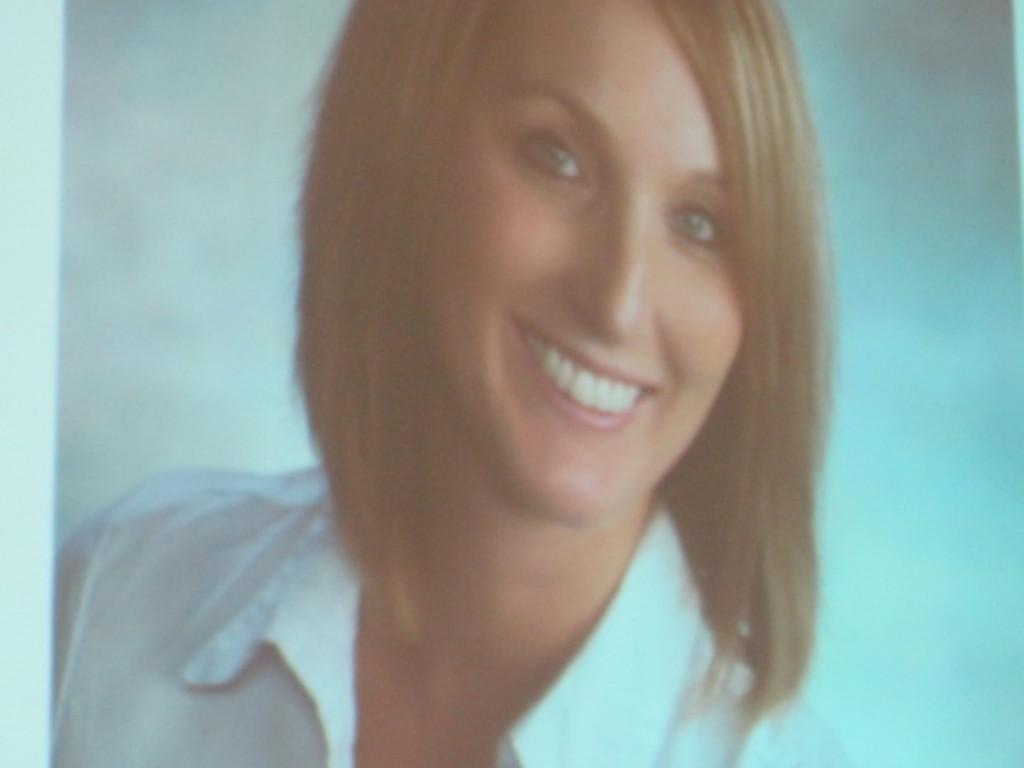Who is the main subject in the image? There is a woman in the image. What is the woman wearing? The woman is wearing a white shirt. What expression does the woman have? The woman is smiling. What is the color of the background in the image? The background of the image is white. What type of zinc is present in the image? There is no zinc present in the image. What authority figure can be seen in the image? There is no authority figure present in the image. 